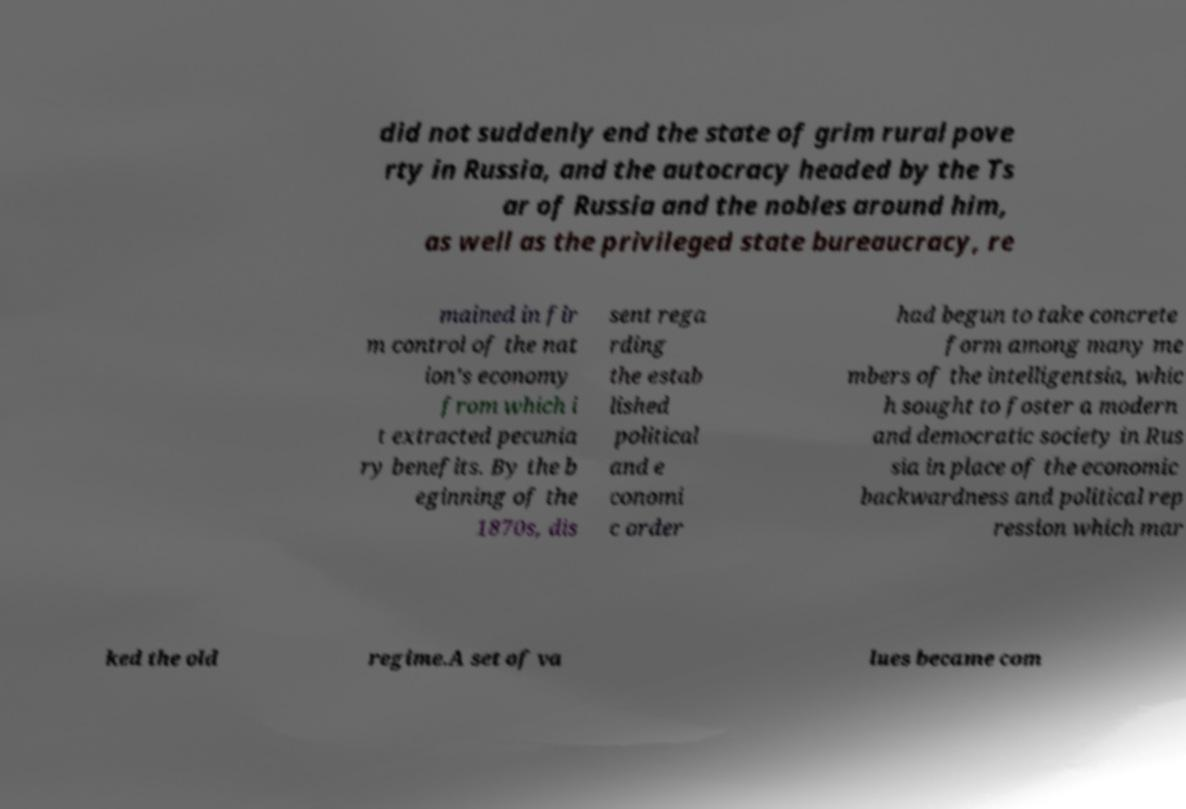Could you extract and type out the text from this image? did not suddenly end the state of grim rural pove rty in Russia, and the autocracy headed by the Ts ar of Russia and the nobles around him, as well as the privileged state bureaucracy, re mained in fir m control of the nat ion's economy from which i t extracted pecunia ry benefits. By the b eginning of the 1870s, dis sent rega rding the estab lished political and e conomi c order had begun to take concrete form among many me mbers of the intelligentsia, whic h sought to foster a modern and democratic society in Rus sia in place of the economic backwardness and political rep ression which mar ked the old regime.A set of va lues became com 